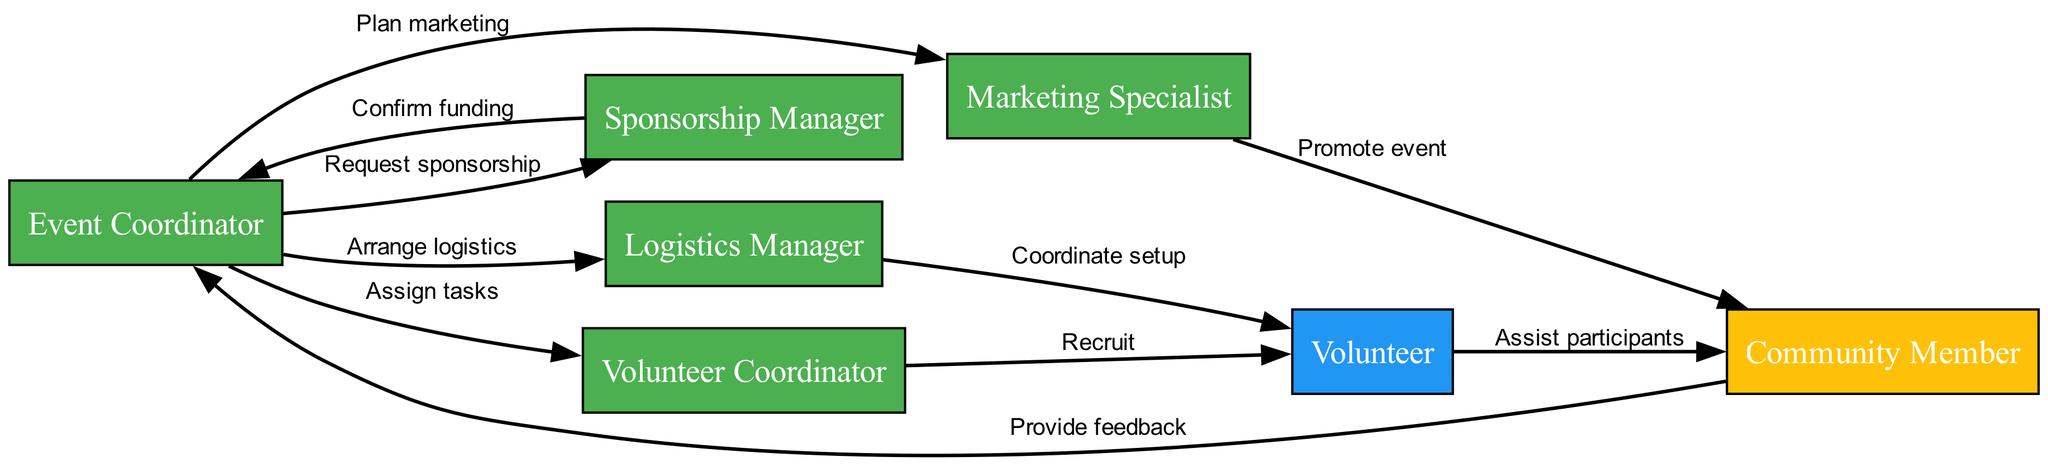What's the total number of nodes in the diagram? The diagram contains eight distinct elements: Event Coordinator, Volunteer Coordinator, Volunteer, Community Member, Sponsorship Manager, Marketing Specialist, and Logistics Manager. Counting these nodes gives a total of eight.
Answer: 8 Which role does "Sponsorship Manager" represent? The Sponsorship Manager's role is categorized as "Staff" in the diagram. This is based on the information provided in the elements list and can be easily identified as it appears alongside the specific responsibilities of different roles.
Answer: Staff How many edges (interactions) connect the "Event Coordinator" to other nodes? The Event Coordinator interacts with four different nodes through specific assignments: assigning tasks to the Volunteer Coordinator, requesting sponsorship from the Sponsorship Manager, planning marketing with the Marketing Specialist, and arranging logistics with the Logistics Manager. Therefore, there are four outgoing edges.
Answer: 4 What is the interaction label between "Volunteer Coordinator" and "Volunteer"? The interaction label between the Volunteer Coordinator and the Volunteer is "Recruit." This is directly stated in the interaction sequence listed in the provided data.
Answer: Recruit Which node provides feedback to the "Event Coordinator"? The Community Member is the node that provides feedback to the Event Coordinator. The arrow shows a return interaction, clearly indicating their relationship in providing feedback after participating in the event.
Answer: Community Member What responsibility is associated with the "Marketing Specialist"? The Marketing Specialist's responsibility is to "Promote the event to the community." This responsibility is explicitly mentioned in the diagram's details about each node's attributes.
Answer: Promote the event to the community Which two roles are involved in coordinating event logistics? The roles involved in coordinating event logistics are the Logistics Manager and the Volunteer. The Logistics Manager handles the venue setup and material procurement, while the Volunteer assists in various event tasks, as indicated in their respective responsibilities and interactions.
Answer: Logistics Manager and Volunteer How does the "Sponsorship Manager" contribute to the event? The Sponsorship Manager contributes to the event by securing funding and sponsorships. This role is explicitly defined in the diagram, reflecting its importance in supporting the event financially.
Answer: Secure funding and sponsorships What is the final interaction in the sequence? The final interaction in the sequence is the Community Member providing feedback to the Event Coordinator. This signifies the closure of the event planning and execution process, reflecting community engagement.
Answer: Provide feedback 